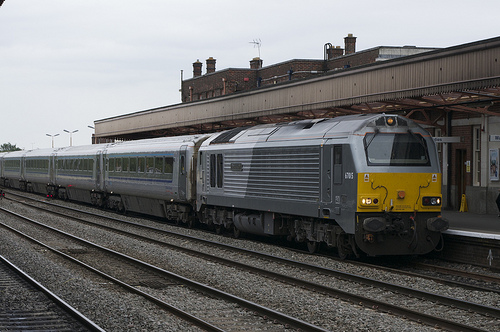Describe the architectural style of the train station visible behind the train. The train station showcases a traditional architectural style, evident from its symmetrical layout and the use of classic roofing and brickwork, providing a historical ambiance to the setting. 